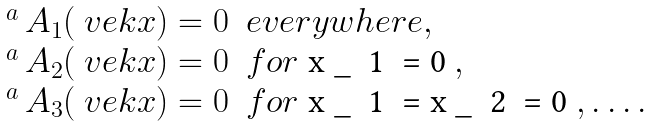<formula> <loc_0><loc_0><loc_500><loc_500>\begin{array} { l l } ^ { a } \, A _ { 1 } ( \ v e k { x } ) = 0 & e v e r y w h e r e , \\ ^ { a } \, A _ { 2 } ( \ v e k { x } ) = 0 & f o r $ x _ { 1 } = 0 $ , \\ ^ { a } \, A _ { 3 } ( \ v e k { x } ) = 0 & f o r $ x _ { 1 } = x _ { 2 } = 0 $ , \dots . \end{array}</formula> 